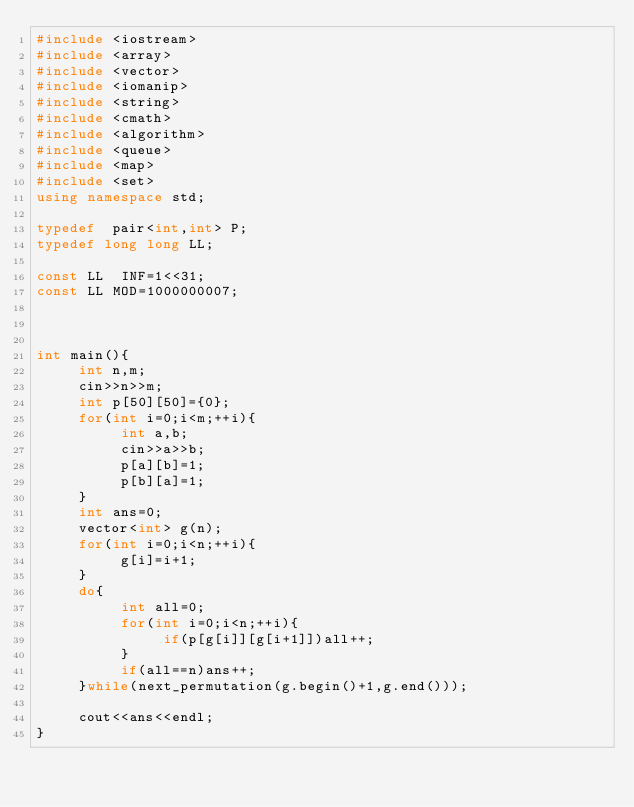Convert code to text. <code><loc_0><loc_0><loc_500><loc_500><_C++_>#include <iostream>
#include <array>
#include <vector>
#include <iomanip>
#include <string>
#include <cmath>
#include <algorithm>
#include <queue>
#include <map>
#include <set>
using namespace std;

typedef  pair<int,int> P;
typedef long long LL;

const LL  INF=1<<31;
const LL MOD=1000000007;



int main(){
     int n,m;
     cin>>n>>m;
     int p[50][50]={0};
     for(int i=0;i<m;++i){
          int a,b;
          cin>>a>>b;
          p[a][b]=1;
          p[b][a]=1;
     }
     int ans=0;
     vector<int> g(n);
     for(int i=0;i<n;++i){
          g[i]=i+1;
     }
     do{
          int all=0;
          for(int i=0;i<n;++i){
               if(p[g[i]][g[i+1]])all++;
          }
          if(all==n)ans++;
     }while(next_permutation(g.begin()+1,g.end()));
     
     cout<<ans<<endl;
}</code> 